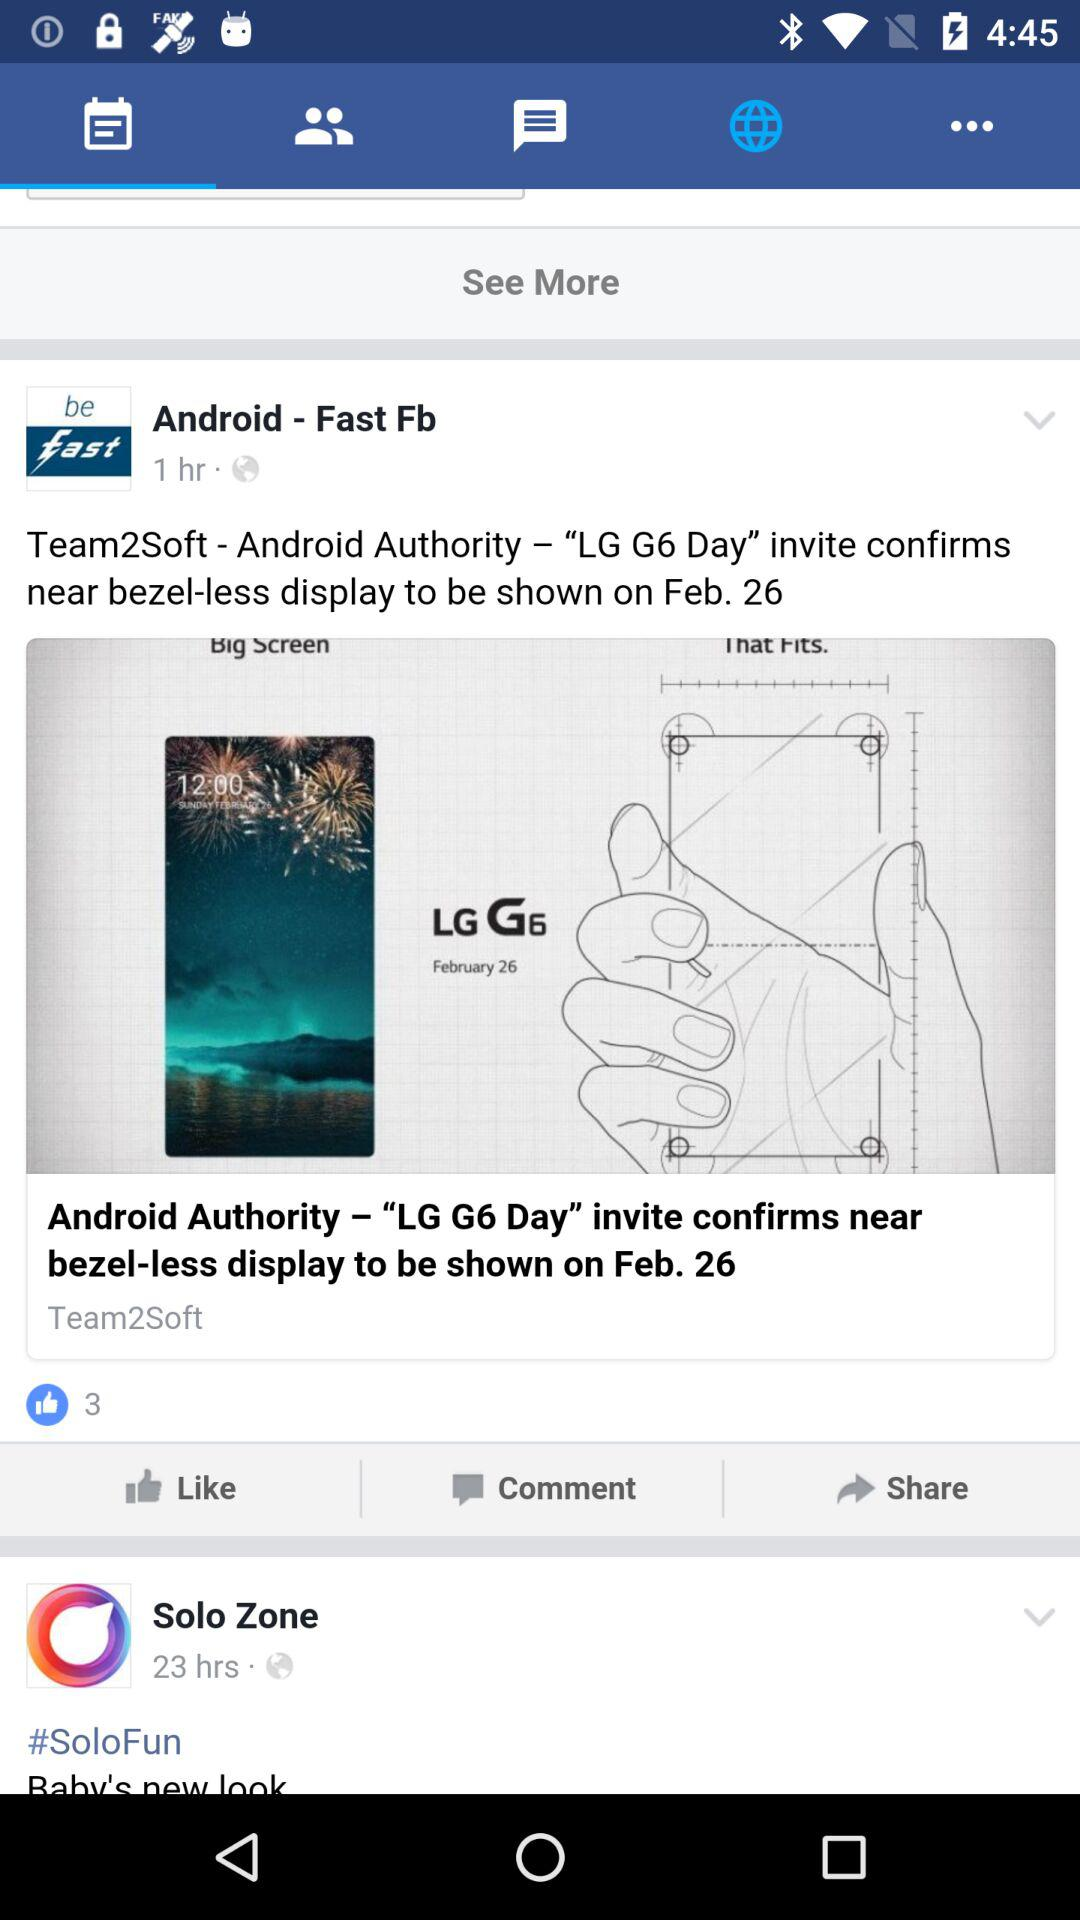How many hours ago was the post posted by Solo Zone? The post was posted 23 hours ago. 